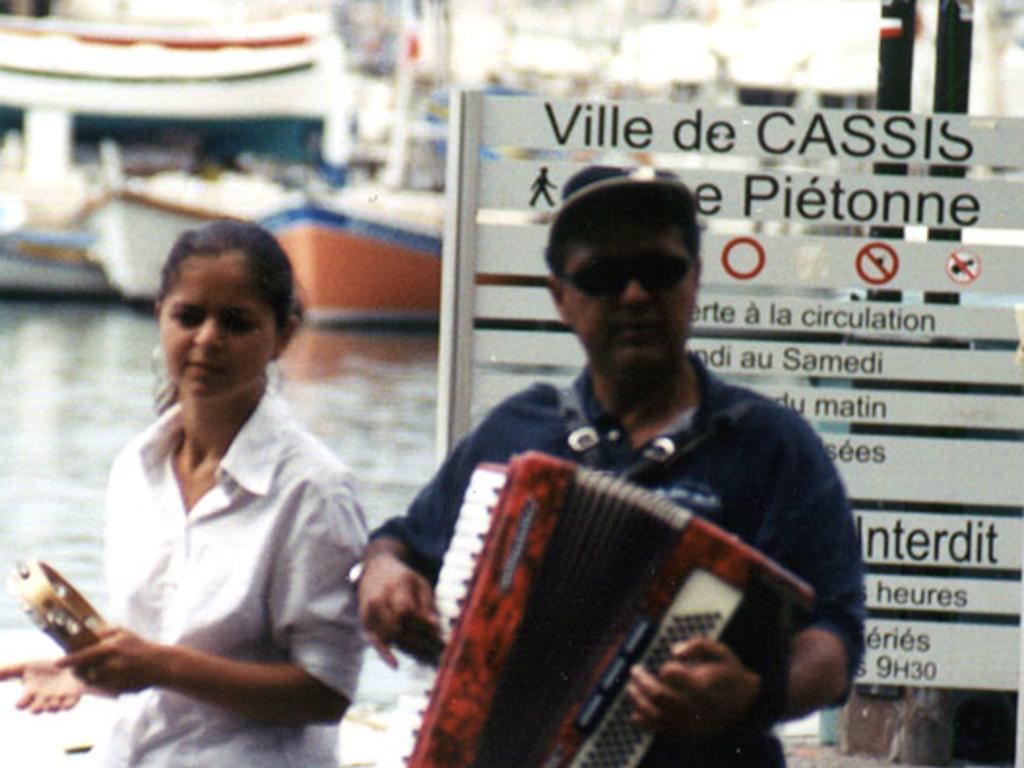Describe this image in one or two sentences. In this image we can see a man and a woman holding the musical instruments. On the backside we can see a board with some text on it, poles and some boats in a water body. 